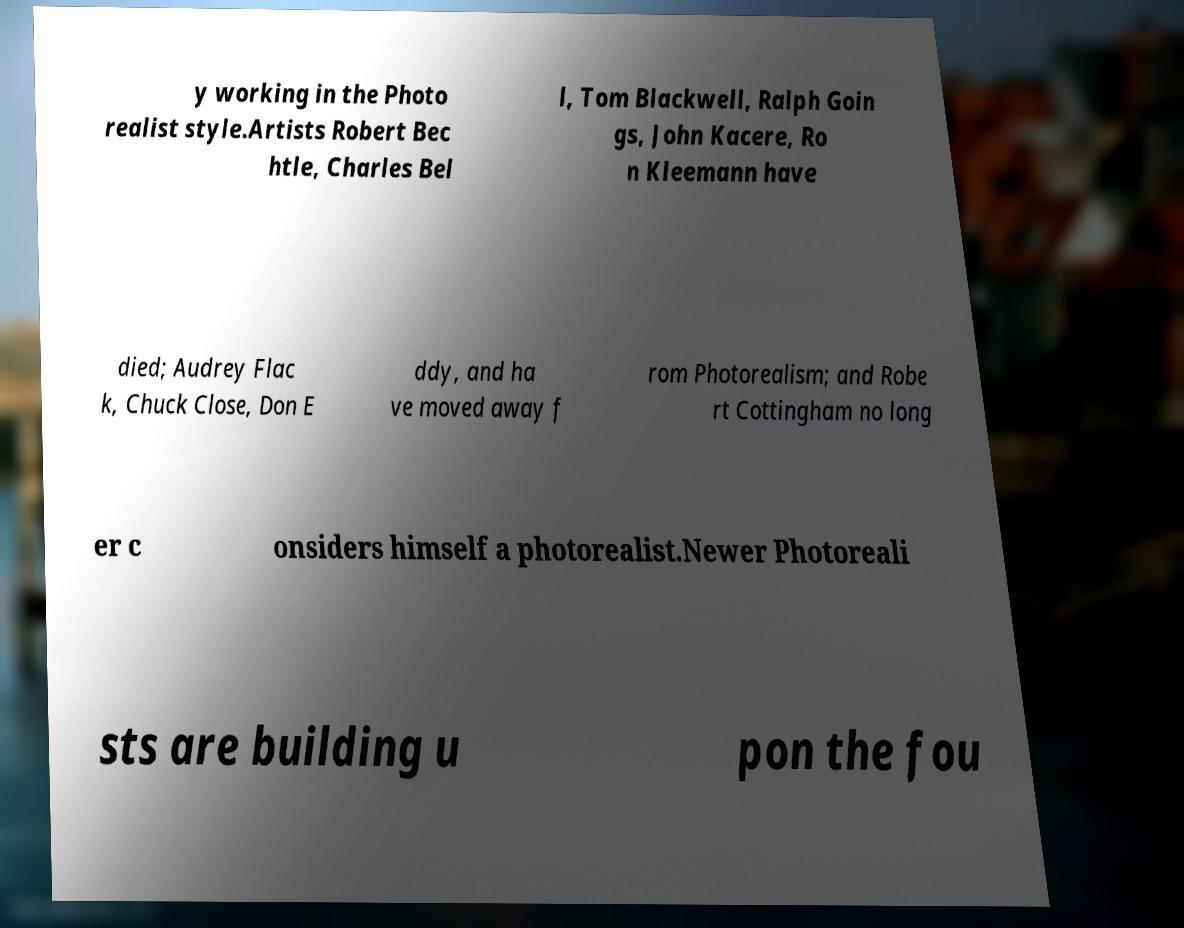Could you extract and type out the text from this image? y working in the Photo realist style.Artists Robert Bec htle, Charles Bel l, Tom Blackwell, Ralph Goin gs, John Kacere, Ro n Kleemann have died; Audrey Flac k, Chuck Close, Don E ddy, and ha ve moved away f rom Photorealism; and Robe rt Cottingham no long er c onsiders himself a photorealist.Newer Photoreali sts are building u pon the fou 